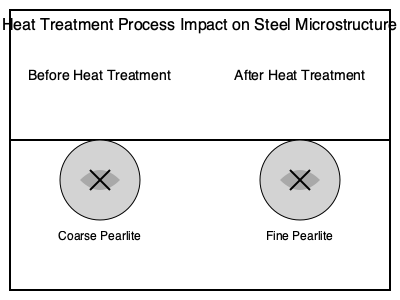How does the heat treatment process affect the microstructure and mechanical properties of steel used in automotive chassis components, and what is the primary reason for this change? 1. Initial microstructure: Before heat treatment, steel typically has a coarse pearlite structure, consisting of alternating layers of ferrite and cementite.

2. Heat treatment process: The steel is heated to its austenitic temperature range (typically 800-1000°C), held for a specific time, and then cooled at a controlled rate.

3. Austenization: During heating, the pearlite structure dissolves, and the steel transforms into austenite (face-centered cubic crystal structure).

4. Cooling rate: The controlled cooling rate determines the final microstructure. Faster cooling rates result in finer microstructures.

5. Microstructure transformation: As the steel cools, austenite transforms back into pearlite. The cooling rate affects the spacing between ferrite and cementite layers.

6. Fine pearlite formation: Faster cooling rates produce fine pearlite with closely spaced ferrite and cementite layers.

7. Mechanical properties: Fine pearlite has improved mechanical properties compared to coarse pearlite:
   a. Increased strength: The finer structure creates more interfaces, impeding dislocation movement.
   b. Improved hardness: Smaller grain size contributes to higher hardness.
   c. Enhanced toughness: Finer structures generally exhibit better impact resistance.

8. Primary reason for change: The controlled cooling rate during heat treatment is the primary factor affecting the final microstructure. It determines the time available for carbon diffusion and grain growth.

9. Application in chassis components: The improved mechanical properties of heat-treated steel make it suitable for automotive chassis components that require high strength, hardness, and toughness.
Answer: Heat treatment refines pearlite structure, increasing strength, hardness, and toughness due to controlled cooling rate. 